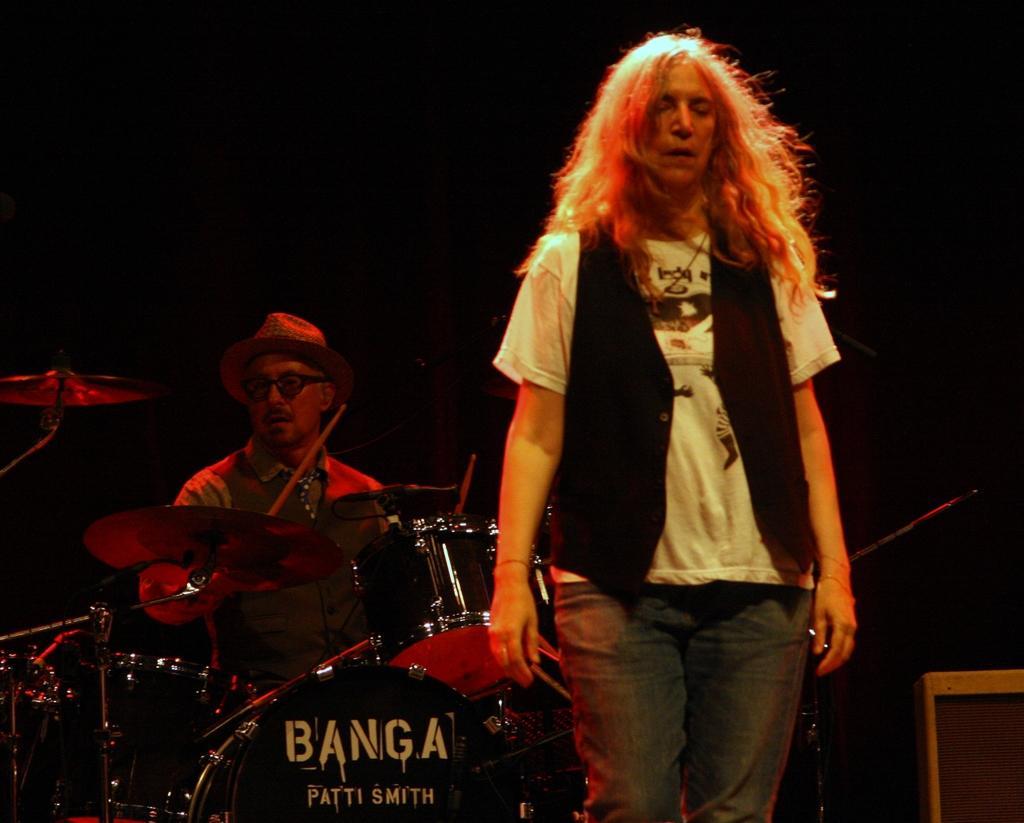Please provide a concise description of this image. In this image there are people, musical instruments and object. One person is holding sticks and in-front of him there are musical instruments. In the background of the image it is dark. 